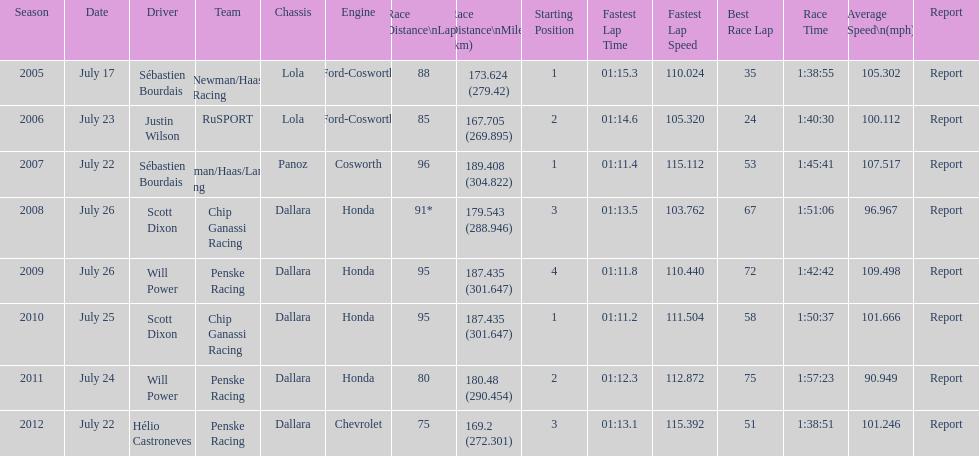How many flags other than france (the first flag) are represented? 3. 